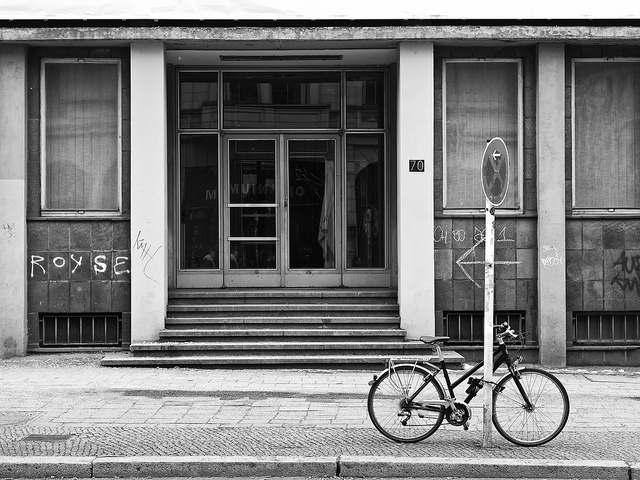Describe the objects in this image and their specific colors. I can see a bicycle in white, lightgray, black, darkgray, and gray tones in this image. 